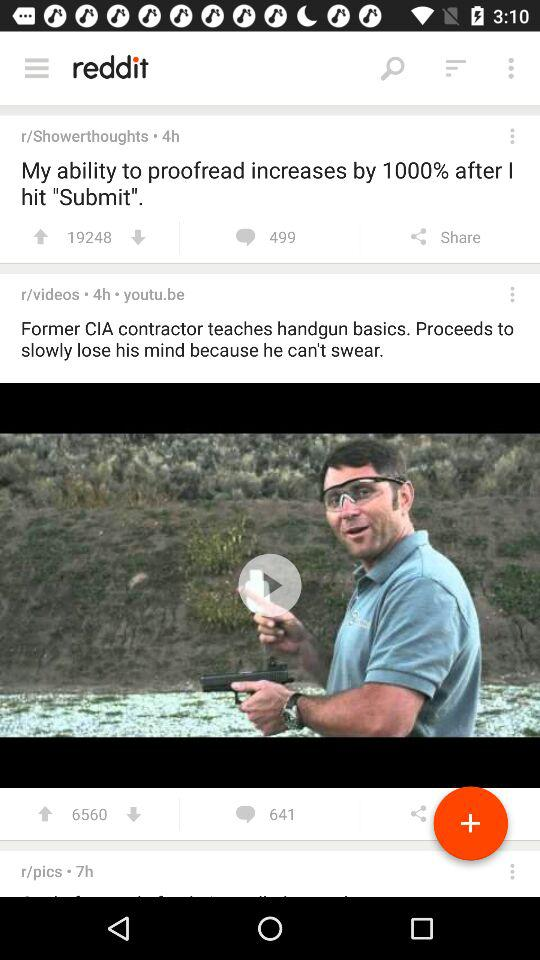What is the number of comments for the post "Former CIA"? The number of comments for the post "Former CIA" is 641. 